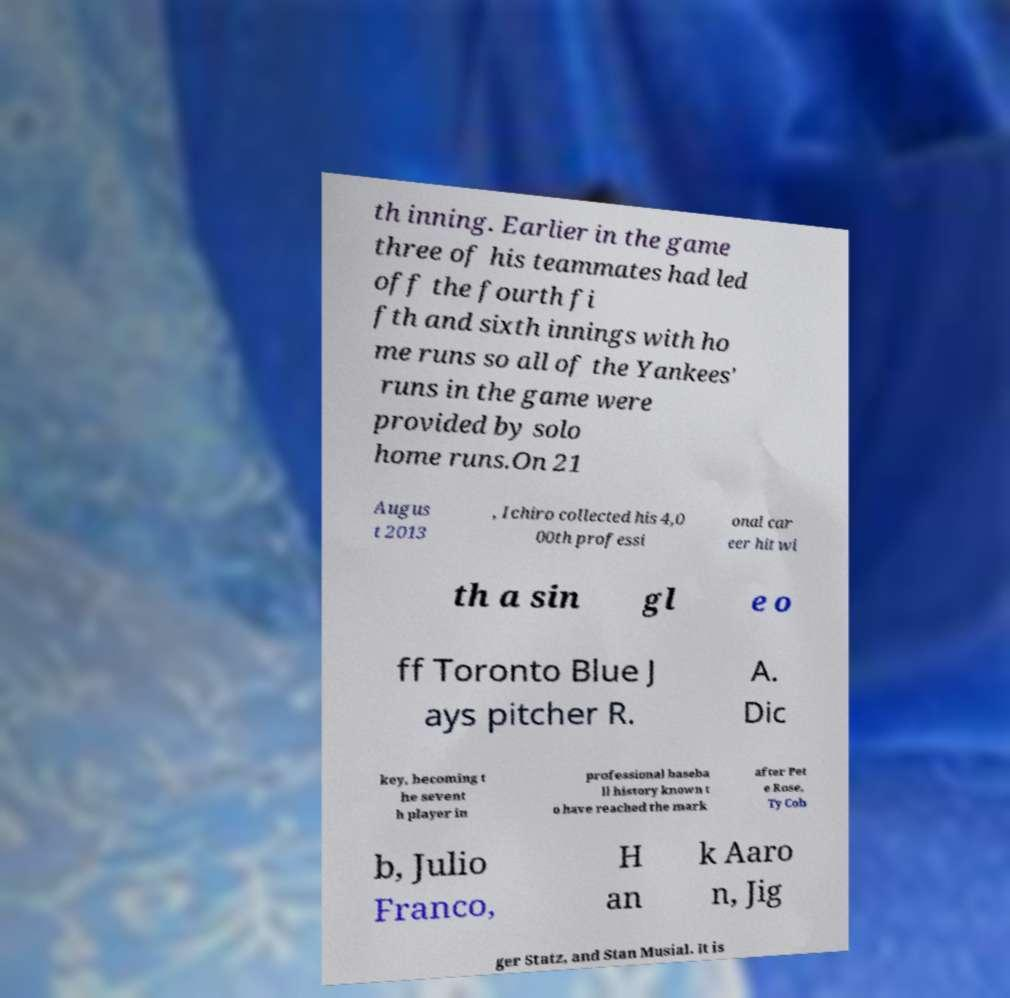What messages or text are displayed in this image? I need them in a readable, typed format. th inning. Earlier in the game three of his teammates had led off the fourth fi fth and sixth innings with ho me runs so all of the Yankees' runs in the game were provided by solo home runs.On 21 Augus t 2013 , Ichiro collected his 4,0 00th professi onal car eer hit wi th a sin gl e o ff Toronto Blue J ays pitcher R. A. Dic key, becoming t he sevent h player in professional baseba ll history known t o have reached the mark after Pet e Rose, Ty Cob b, Julio Franco, H an k Aaro n, Jig ger Statz, and Stan Musial. It is 